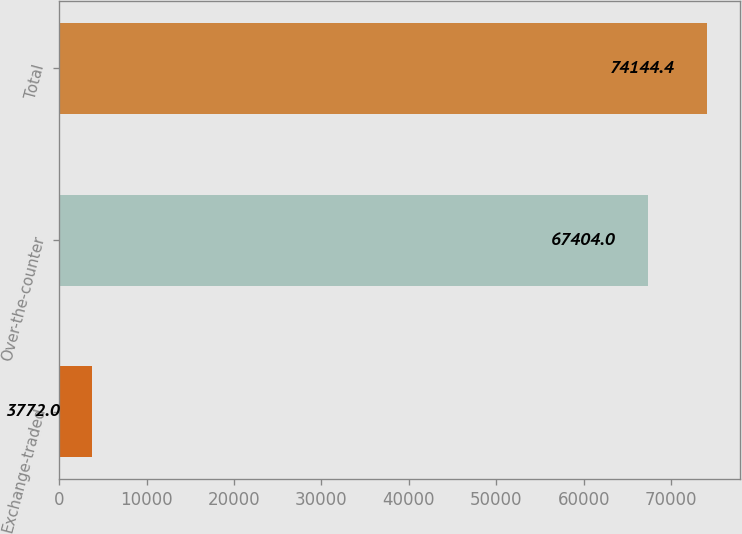Convert chart. <chart><loc_0><loc_0><loc_500><loc_500><bar_chart><fcel>Exchange-traded<fcel>Over-the-counter<fcel>Total<nl><fcel>3772<fcel>67404<fcel>74144.4<nl></chart> 